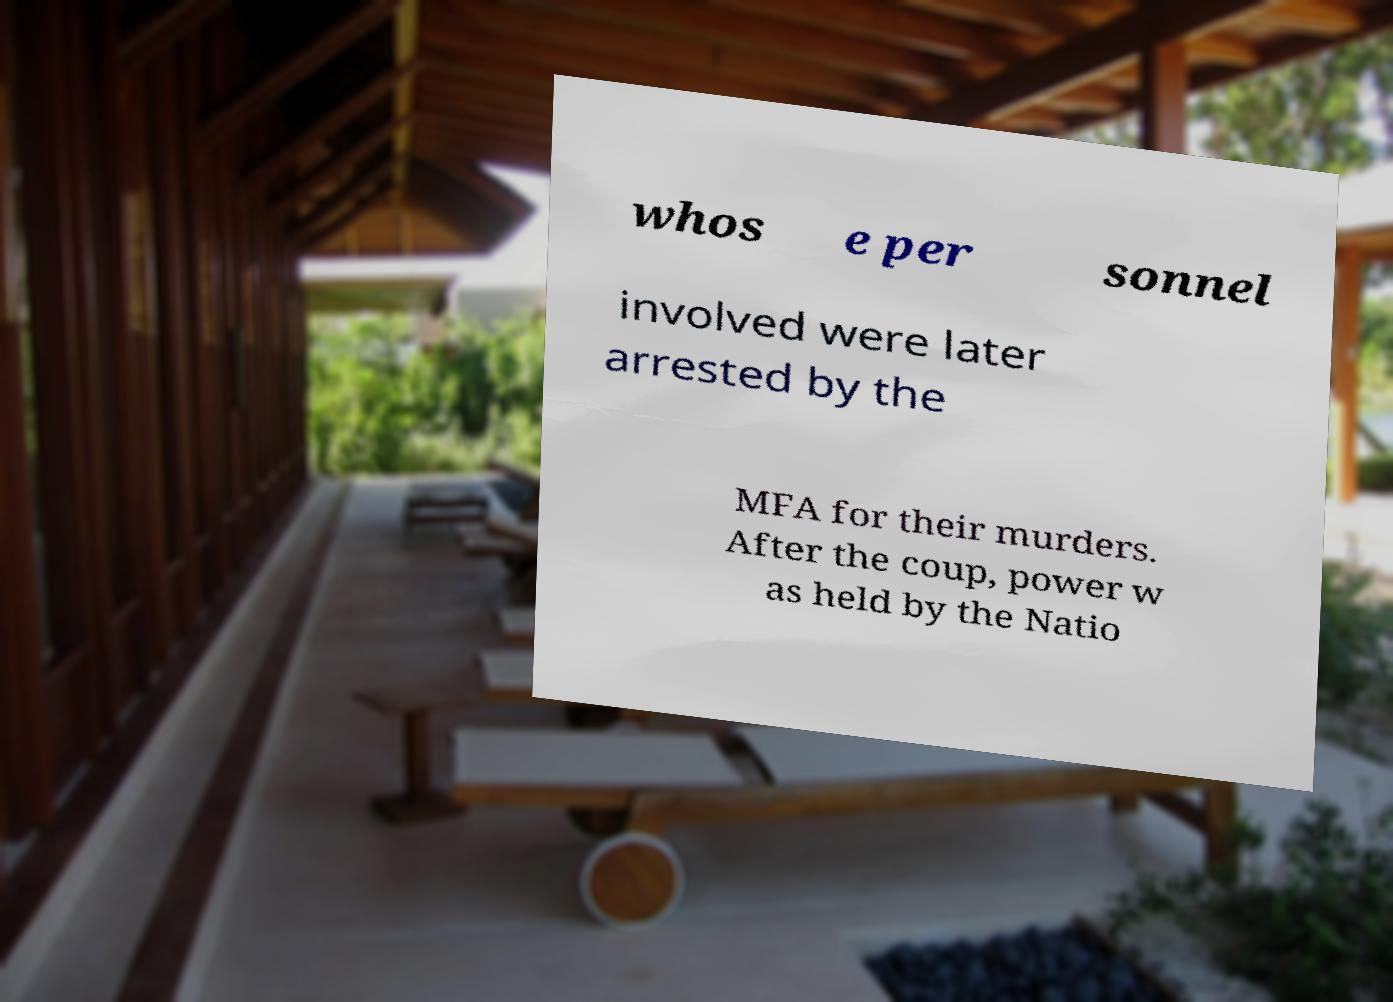Could you assist in decoding the text presented in this image and type it out clearly? whos e per sonnel involved were later arrested by the MFA for their murders. After the coup, power w as held by the Natio 